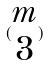<formula> <loc_0><loc_0><loc_500><loc_500>( \begin{matrix} m \\ 3 \end{matrix} )</formula> 